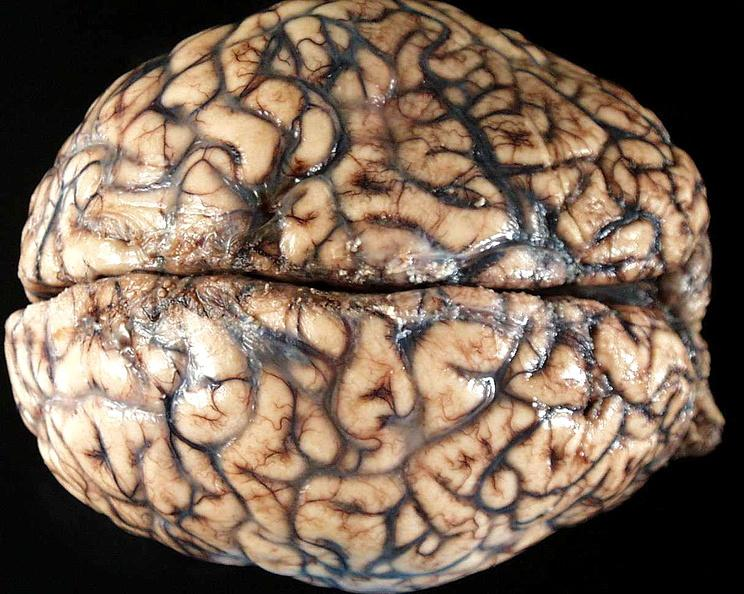does metastatic melanoma show brain, cryptococcal meningitis?
Answer the question using a single word or phrase. No 